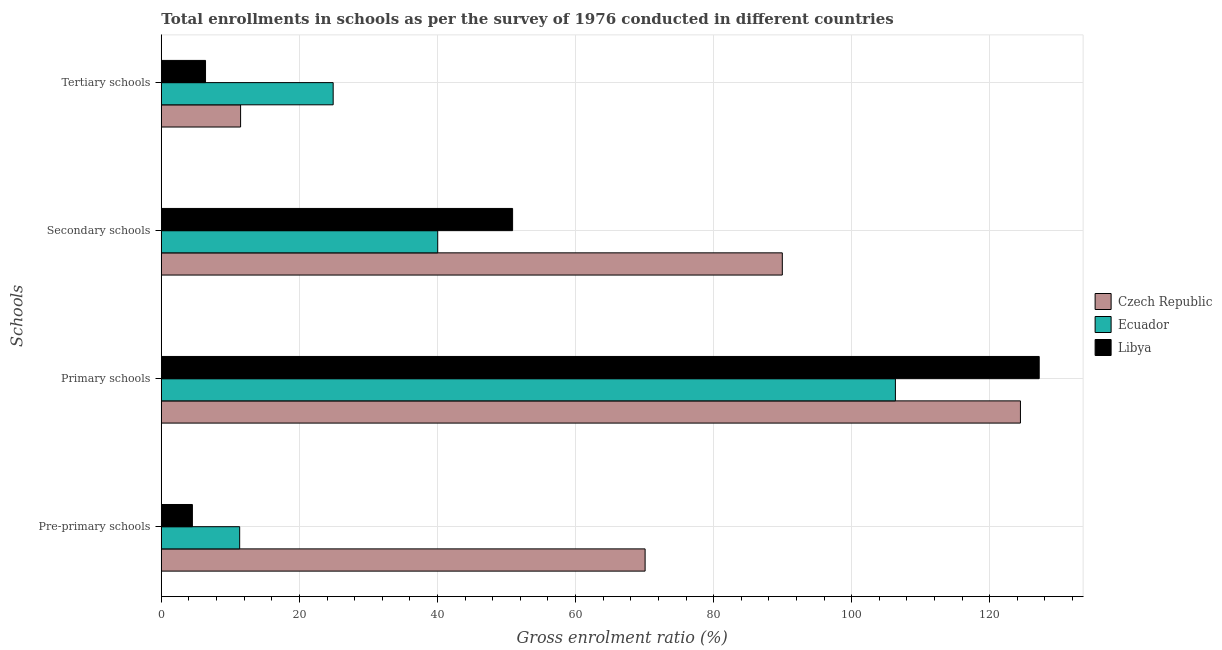How many groups of bars are there?
Your answer should be very brief. 4. Are the number of bars per tick equal to the number of legend labels?
Make the answer very short. Yes. How many bars are there on the 1st tick from the top?
Provide a short and direct response. 3. What is the label of the 1st group of bars from the top?
Your answer should be compact. Tertiary schools. What is the gross enrolment ratio in primary schools in Ecuador?
Your response must be concise. 106.33. Across all countries, what is the maximum gross enrolment ratio in pre-primary schools?
Ensure brevity in your answer.  70.08. Across all countries, what is the minimum gross enrolment ratio in pre-primary schools?
Offer a terse response. 4.5. In which country was the gross enrolment ratio in secondary schools maximum?
Your answer should be very brief. Czech Republic. In which country was the gross enrolment ratio in pre-primary schools minimum?
Offer a terse response. Libya. What is the total gross enrolment ratio in tertiary schools in the graph?
Offer a very short reply. 42.78. What is the difference between the gross enrolment ratio in pre-primary schools in Ecuador and that in Czech Republic?
Your response must be concise. -58.73. What is the difference between the gross enrolment ratio in primary schools in Czech Republic and the gross enrolment ratio in tertiary schools in Libya?
Your answer should be very brief. 118.04. What is the average gross enrolment ratio in pre-primary schools per country?
Make the answer very short. 28.64. What is the difference between the gross enrolment ratio in tertiary schools and gross enrolment ratio in secondary schools in Czech Republic?
Your answer should be compact. -78.47. In how many countries, is the gross enrolment ratio in pre-primary schools greater than 112 %?
Your answer should be very brief. 0. What is the ratio of the gross enrolment ratio in secondary schools in Czech Republic to that in Ecuador?
Keep it short and to the point. 2.25. What is the difference between the highest and the second highest gross enrolment ratio in tertiary schools?
Provide a short and direct response. 13.41. What is the difference between the highest and the lowest gross enrolment ratio in secondary schools?
Your answer should be compact. 49.92. In how many countries, is the gross enrolment ratio in tertiary schools greater than the average gross enrolment ratio in tertiary schools taken over all countries?
Your answer should be very brief. 1. Is the sum of the gross enrolment ratio in primary schools in Czech Republic and Ecuador greater than the maximum gross enrolment ratio in secondary schools across all countries?
Ensure brevity in your answer.  Yes. What does the 2nd bar from the top in Tertiary schools represents?
Your response must be concise. Ecuador. What does the 3rd bar from the bottom in Tertiary schools represents?
Make the answer very short. Libya. Is it the case that in every country, the sum of the gross enrolment ratio in pre-primary schools and gross enrolment ratio in primary schools is greater than the gross enrolment ratio in secondary schools?
Provide a short and direct response. Yes. Are all the bars in the graph horizontal?
Keep it short and to the point. Yes. How many countries are there in the graph?
Your response must be concise. 3. What is the difference between two consecutive major ticks on the X-axis?
Offer a very short reply. 20. What is the title of the graph?
Offer a terse response. Total enrollments in schools as per the survey of 1976 conducted in different countries. What is the label or title of the X-axis?
Provide a short and direct response. Gross enrolment ratio (%). What is the label or title of the Y-axis?
Ensure brevity in your answer.  Schools. What is the Gross enrolment ratio (%) of Czech Republic in Pre-primary schools?
Offer a terse response. 70.08. What is the Gross enrolment ratio (%) in Ecuador in Pre-primary schools?
Make the answer very short. 11.35. What is the Gross enrolment ratio (%) in Libya in Pre-primary schools?
Offer a very short reply. 4.5. What is the Gross enrolment ratio (%) in Czech Republic in Primary schools?
Keep it short and to the point. 124.44. What is the Gross enrolment ratio (%) of Ecuador in Primary schools?
Your response must be concise. 106.33. What is the Gross enrolment ratio (%) in Libya in Primary schools?
Your answer should be compact. 127.16. What is the Gross enrolment ratio (%) of Czech Republic in Secondary schools?
Your response must be concise. 89.95. What is the Gross enrolment ratio (%) in Ecuador in Secondary schools?
Offer a terse response. 40.04. What is the Gross enrolment ratio (%) in Libya in Secondary schools?
Keep it short and to the point. 50.88. What is the Gross enrolment ratio (%) of Czech Republic in Tertiary schools?
Keep it short and to the point. 11.48. What is the Gross enrolment ratio (%) of Ecuador in Tertiary schools?
Make the answer very short. 24.89. What is the Gross enrolment ratio (%) of Libya in Tertiary schools?
Make the answer very short. 6.41. Across all Schools, what is the maximum Gross enrolment ratio (%) in Czech Republic?
Offer a very short reply. 124.44. Across all Schools, what is the maximum Gross enrolment ratio (%) of Ecuador?
Keep it short and to the point. 106.33. Across all Schools, what is the maximum Gross enrolment ratio (%) in Libya?
Offer a terse response. 127.16. Across all Schools, what is the minimum Gross enrolment ratio (%) of Czech Republic?
Offer a terse response. 11.48. Across all Schools, what is the minimum Gross enrolment ratio (%) in Ecuador?
Ensure brevity in your answer.  11.35. Across all Schools, what is the minimum Gross enrolment ratio (%) of Libya?
Ensure brevity in your answer.  4.5. What is the total Gross enrolment ratio (%) of Czech Republic in the graph?
Keep it short and to the point. 295.96. What is the total Gross enrolment ratio (%) of Ecuador in the graph?
Provide a short and direct response. 182.61. What is the total Gross enrolment ratio (%) in Libya in the graph?
Provide a short and direct response. 188.95. What is the difference between the Gross enrolment ratio (%) in Czech Republic in Pre-primary schools and that in Primary schools?
Your answer should be compact. -54.37. What is the difference between the Gross enrolment ratio (%) of Ecuador in Pre-primary schools and that in Primary schools?
Your answer should be compact. -94.98. What is the difference between the Gross enrolment ratio (%) in Libya in Pre-primary schools and that in Primary schools?
Your answer should be compact. -122.66. What is the difference between the Gross enrolment ratio (%) in Czech Republic in Pre-primary schools and that in Secondary schools?
Your answer should be compact. -19.87. What is the difference between the Gross enrolment ratio (%) in Ecuador in Pre-primary schools and that in Secondary schools?
Give a very brief answer. -28.69. What is the difference between the Gross enrolment ratio (%) of Libya in Pre-primary schools and that in Secondary schools?
Offer a terse response. -46.38. What is the difference between the Gross enrolment ratio (%) in Czech Republic in Pre-primary schools and that in Tertiary schools?
Offer a terse response. 58.59. What is the difference between the Gross enrolment ratio (%) of Ecuador in Pre-primary schools and that in Tertiary schools?
Make the answer very short. -13.54. What is the difference between the Gross enrolment ratio (%) in Libya in Pre-primary schools and that in Tertiary schools?
Your answer should be very brief. -1.9. What is the difference between the Gross enrolment ratio (%) of Czech Republic in Primary schools and that in Secondary schools?
Offer a very short reply. 34.49. What is the difference between the Gross enrolment ratio (%) in Ecuador in Primary schools and that in Secondary schools?
Keep it short and to the point. 66.29. What is the difference between the Gross enrolment ratio (%) of Libya in Primary schools and that in Secondary schools?
Your answer should be compact. 76.28. What is the difference between the Gross enrolment ratio (%) in Czech Republic in Primary schools and that in Tertiary schools?
Make the answer very short. 112.96. What is the difference between the Gross enrolment ratio (%) of Ecuador in Primary schools and that in Tertiary schools?
Offer a very short reply. 81.44. What is the difference between the Gross enrolment ratio (%) in Libya in Primary schools and that in Tertiary schools?
Give a very brief answer. 120.76. What is the difference between the Gross enrolment ratio (%) in Czech Republic in Secondary schools and that in Tertiary schools?
Provide a succinct answer. 78.47. What is the difference between the Gross enrolment ratio (%) in Ecuador in Secondary schools and that in Tertiary schools?
Ensure brevity in your answer.  15.14. What is the difference between the Gross enrolment ratio (%) of Libya in Secondary schools and that in Tertiary schools?
Offer a terse response. 44.48. What is the difference between the Gross enrolment ratio (%) in Czech Republic in Pre-primary schools and the Gross enrolment ratio (%) in Ecuador in Primary schools?
Offer a terse response. -36.25. What is the difference between the Gross enrolment ratio (%) in Czech Republic in Pre-primary schools and the Gross enrolment ratio (%) in Libya in Primary schools?
Provide a succinct answer. -57.08. What is the difference between the Gross enrolment ratio (%) of Ecuador in Pre-primary schools and the Gross enrolment ratio (%) of Libya in Primary schools?
Give a very brief answer. -115.81. What is the difference between the Gross enrolment ratio (%) in Czech Republic in Pre-primary schools and the Gross enrolment ratio (%) in Ecuador in Secondary schools?
Ensure brevity in your answer.  30.04. What is the difference between the Gross enrolment ratio (%) in Czech Republic in Pre-primary schools and the Gross enrolment ratio (%) in Libya in Secondary schools?
Offer a terse response. 19.2. What is the difference between the Gross enrolment ratio (%) in Ecuador in Pre-primary schools and the Gross enrolment ratio (%) in Libya in Secondary schools?
Ensure brevity in your answer.  -39.53. What is the difference between the Gross enrolment ratio (%) in Czech Republic in Pre-primary schools and the Gross enrolment ratio (%) in Ecuador in Tertiary schools?
Offer a terse response. 45.19. What is the difference between the Gross enrolment ratio (%) in Czech Republic in Pre-primary schools and the Gross enrolment ratio (%) in Libya in Tertiary schools?
Your answer should be very brief. 63.67. What is the difference between the Gross enrolment ratio (%) of Ecuador in Pre-primary schools and the Gross enrolment ratio (%) of Libya in Tertiary schools?
Offer a terse response. 4.95. What is the difference between the Gross enrolment ratio (%) in Czech Republic in Primary schools and the Gross enrolment ratio (%) in Ecuador in Secondary schools?
Provide a short and direct response. 84.41. What is the difference between the Gross enrolment ratio (%) in Czech Republic in Primary schools and the Gross enrolment ratio (%) in Libya in Secondary schools?
Give a very brief answer. 73.56. What is the difference between the Gross enrolment ratio (%) of Ecuador in Primary schools and the Gross enrolment ratio (%) of Libya in Secondary schools?
Ensure brevity in your answer.  55.45. What is the difference between the Gross enrolment ratio (%) of Czech Republic in Primary schools and the Gross enrolment ratio (%) of Ecuador in Tertiary schools?
Offer a terse response. 99.55. What is the difference between the Gross enrolment ratio (%) of Czech Republic in Primary schools and the Gross enrolment ratio (%) of Libya in Tertiary schools?
Your answer should be compact. 118.04. What is the difference between the Gross enrolment ratio (%) in Ecuador in Primary schools and the Gross enrolment ratio (%) in Libya in Tertiary schools?
Offer a very short reply. 99.93. What is the difference between the Gross enrolment ratio (%) of Czech Republic in Secondary schools and the Gross enrolment ratio (%) of Ecuador in Tertiary schools?
Your answer should be very brief. 65.06. What is the difference between the Gross enrolment ratio (%) of Czech Republic in Secondary schools and the Gross enrolment ratio (%) of Libya in Tertiary schools?
Make the answer very short. 83.55. What is the difference between the Gross enrolment ratio (%) of Ecuador in Secondary schools and the Gross enrolment ratio (%) of Libya in Tertiary schools?
Your answer should be compact. 33.63. What is the average Gross enrolment ratio (%) of Czech Republic per Schools?
Make the answer very short. 73.99. What is the average Gross enrolment ratio (%) in Ecuador per Schools?
Keep it short and to the point. 45.65. What is the average Gross enrolment ratio (%) of Libya per Schools?
Provide a short and direct response. 47.24. What is the difference between the Gross enrolment ratio (%) in Czech Republic and Gross enrolment ratio (%) in Ecuador in Pre-primary schools?
Your answer should be very brief. 58.73. What is the difference between the Gross enrolment ratio (%) in Czech Republic and Gross enrolment ratio (%) in Libya in Pre-primary schools?
Give a very brief answer. 65.58. What is the difference between the Gross enrolment ratio (%) of Ecuador and Gross enrolment ratio (%) of Libya in Pre-primary schools?
Your answer should be very brief. 6.85. What is the difference between the Gross enrolment ratio (%) in Czech Republic and Gross enrolment ratio (%) in Ecuador in Primary schools?
Offer a very short reply. 18.11. What is the difference between the Gross enrolment ratio (%) in Czech Republic and Gross enrolment ratio (%) in Libya in Primary schools?
Your response must be concise. -2.72. What is the difference between the Gross enrolment ratio (%) of Ecuador and Gross enrolment ratio (%) of Libya in Primary schools?
Give a very brief answer. -20.83. What is the difference between the Gross enrolment ratio (%) in Czech Republic and Gross enrolment ratio (%) in Ecuador in Secondary schools?
Offer a terse response. 49.92. What is the difference between the Gross enrolment ratio (%) in Czech Republic and Gross enrolment ratio (%) in Libya in Secondary schools?
Ensure brevity in your answer.  39.07. What is the difference between the Gross enrolment ratio (%) in Ecuador and Gross enrolment ratio (%) in Libya in Secondary schools?
Offer a very short reply. -10.85. What is the difference between the Gross enrolment ratio (%) in Czech Republic and Gross enrolment ratio (%) in Ecuador in Tertiary schools?
Your response must be concise. -13.41. What is the difference between the Gross enrolment ratio (%) in Czech Republic and Gross enrolment ratio (%) in Libya in Tertiary schools?
Offer a very short reply. 5.08. What is the difference between the Gross enrolment ratio (%) in Ecuador and Gross enrolment ratio (%) in Libya in Tertiary schools?
Provide a succinct answer. 18.49. What is the ratio of the Gross enrolment ratio (%) of Czech Republic in Pre-primary schools to that in Primary schools?
Provide a short and direct response. 0.56. What is the ratio of the Gross enrolment ratio (%) of Ecuador in Pre-primary schools to that in Primary schools?
Your answer should be very brief. 0.11. What is the ratio of the Gross enrolment ratio (%) in Libya in Pre-primary schools to that in Primary schools?
Ensure brevity in your answer.  0.04. What is the ratio of the Gross enrolment ratio (%) of Czech Republic in Pre-primary schools to that in Secondary schools?
Ensure brevity in your answer.  0.78. What is the ratio of the Gross enrolment ratio (%) of Ecuador in Pre-primary schools to that in Secondary schools?
Offer a very short reply. 0.28. What is the ratio of the Gross enrolment ratio (%) in Libya in Pre-primary schools to that in Secondary schools?
Provide a succinct answer. 0.09. What is the ratio of the Gross enrolment ratio (%) of Czech Republic in Pre-primary schools to that in Tertiary schools?
Ensure brevity in your answer.  6.1. What is the ratio of the Gross enrolment ratio (%) of Ecuador in Pre-primary schools to that in Tertiary schools?
Your response must be concise. 0.46. What is the ratio of the Gross enrolment ratio (%) in Libya in Pre-primary schools to that in Tertiary schools?
Offer a very short reply. 0.7. What is the ratio of the Gross enrolment ratio (%) of Czech Republic in Primary schools to that in Secondary schools?
Provide a short and direct response. 1.38. What is the ratio of the Gross enrolment ratio (%) of Ecuador in Primary schools to that in Secondary schools?
Keep it short and to the point. 2.66. What is the ratio of the Gross enrolment ratio (%) of Libya in Primary schools to that in Secondary schools?
Your answer should be very brief. 2.5. What is the ratio of the Gross enrolment ratio (%) in Czech Republic in Primary schools to that in Tertiary schools?
Make the answer very short. 10.84. What is the ratio of the Gross enrolment ratio (%) in Ecuador in Primary schools to that in Tertiary schools?
Offer a terse response. 4.27. What is the ratio of the Gross enrolment ratio (%) of Libya in Primary schools to that in Tertiary schools?
Your answer should be very brief. 19.85. What is the ratio of the Gross enrolment ratio (%) in Czech Republic in Secondary schools to that in Tertiary schools?
Provide a short and direct response. 7.83. What is the ratio of the Gross enrolment ratio (%) in Ecuador in Secondary schools to that in Tertiary schools?
Your response must be concise. 1.61. What is the ratio of the Gross enrolment ratio (%) of Libya in Secondary schools to that in Tertiary schools?
Provide a short and direct response. 7.94. What is the difference between the highest and the second highest Gross enrolment ratio (%) of Czech Republic?
Offer a very short reply. 34.49. What is the difference between the highest and the second highest Gross enrolment ratio (%) in Ecuador?
Make the answer very short. 66.29. What is the difference between the highest and the second highest Gross enrolment ratio (%) in Libya?
Make the answer very short. 76.28. What is the difference between the highest and the lowest Gross enrolment ratio (%) in Czech Republic?
Offer a very short reply. 112.96. What is the difference between the highest and the lowest Gross enrolment ratio (%) of Ecuador?
Give a very brief answer. 94.98. What is the difference between the highest and the lowest Gross enrolment ratio (%) of Libya?
Provide a succinct answer. 122.66. 